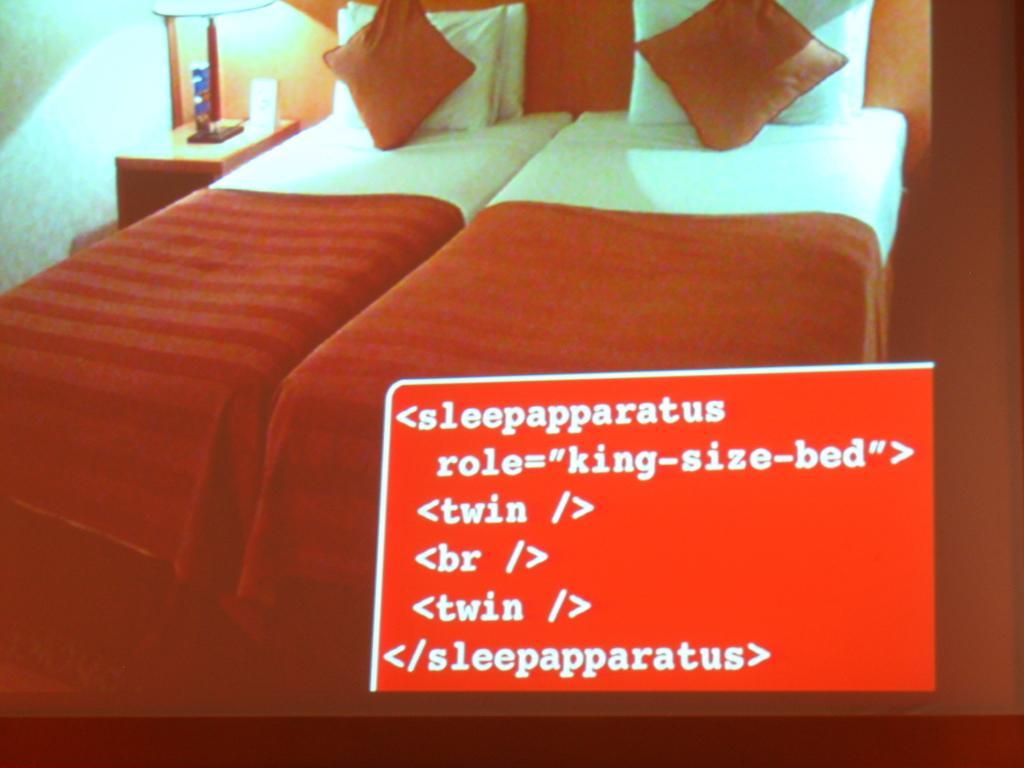Please provide a concise description of this image. On these beds there are bed-sheets and pillows. Beside this bed there is a table, on this table there is a lamp and things. Something written on this picture. This is wall. 